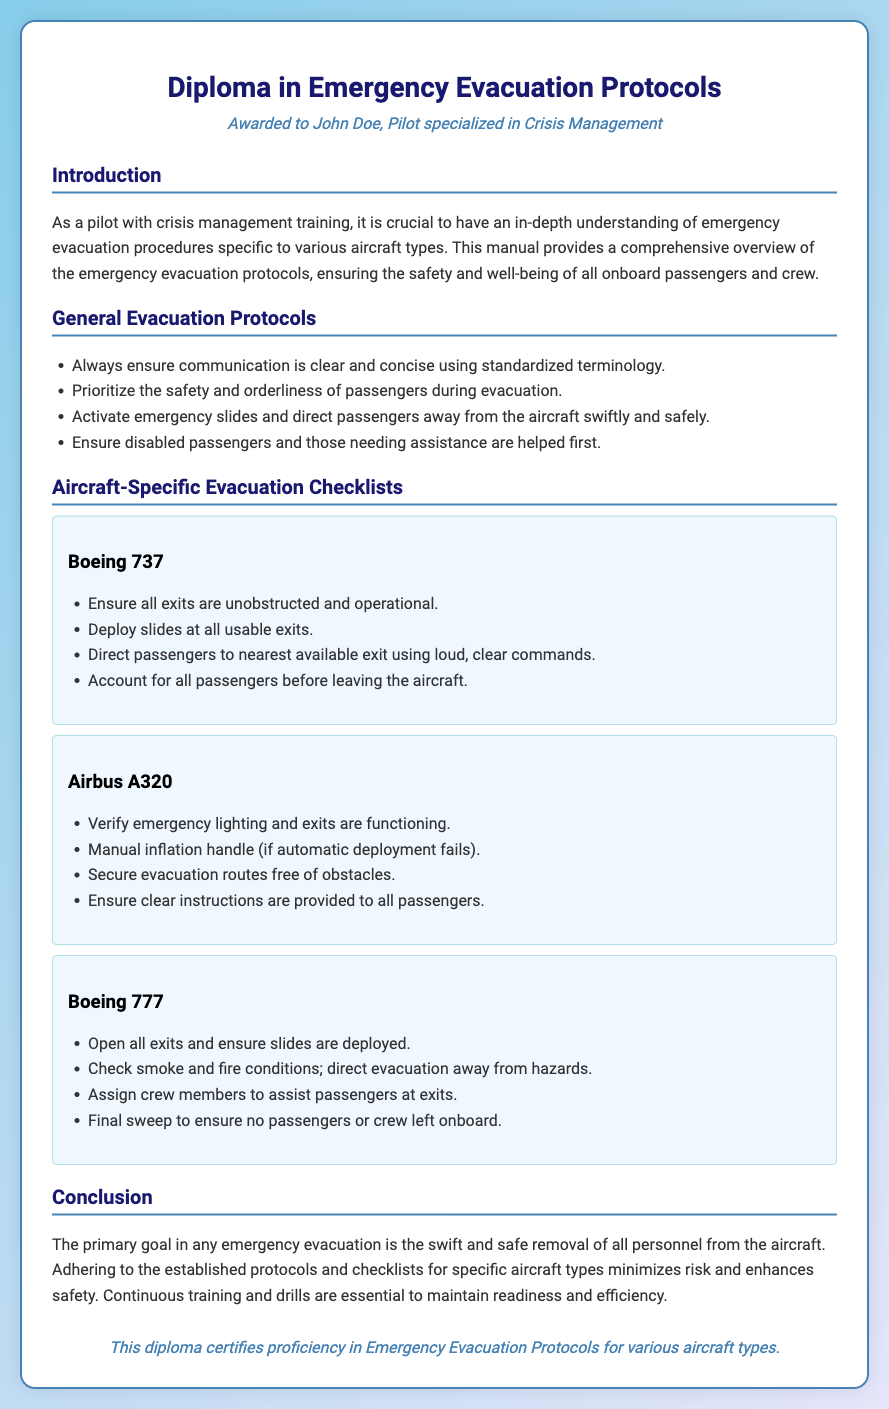what is the title of the diploma? The title as stated in the document is provided in the header, which clearly indicates the focus on emergency evacuation protocols.
Answer: Diploma in Emergency Evacuation Protocols who is awarded the diploma? The name of the individual receiving the diploma is provided in the persona section of the document.
Answer: John Doe what type of aircraft does the checklist include for Boeing 737? The specific section pertaining to the Boeing 737 offers a defined checklist of actions for evacuation.
Answer: Ensure all exits are unobstructed and operational how many aircraft types are included in the document? The document enumerates distinct aircraft-specific checklists, providing an indication of the variety covered.
Answer: Three what is the primary goal of an emergency evacuation? The conclusion section summarizes the central objective of any emergency evacuation, emphasizing its importance.
Answer: Swift and safe removal of all personnel what should be checked before leaving the aircraft according to Boeing 777 checklist? The checklist for Boeing 777 specifies a critical step to ensure no one is left behind, which is paramount in an evacuation scenario.
Answer: Final sweep to ensure no passengers or crew left onboard what is mentioned as essential for maintaining readiness and efficiency? The conclusion outlines activities necessary for preparedness, especially in crisis scenarios for pilots.
Answer: Continuous training and drills what is the color used for the header text? The document specifies the styling of text elements, including the header which stands out with its color choice.
Answer: #191970 